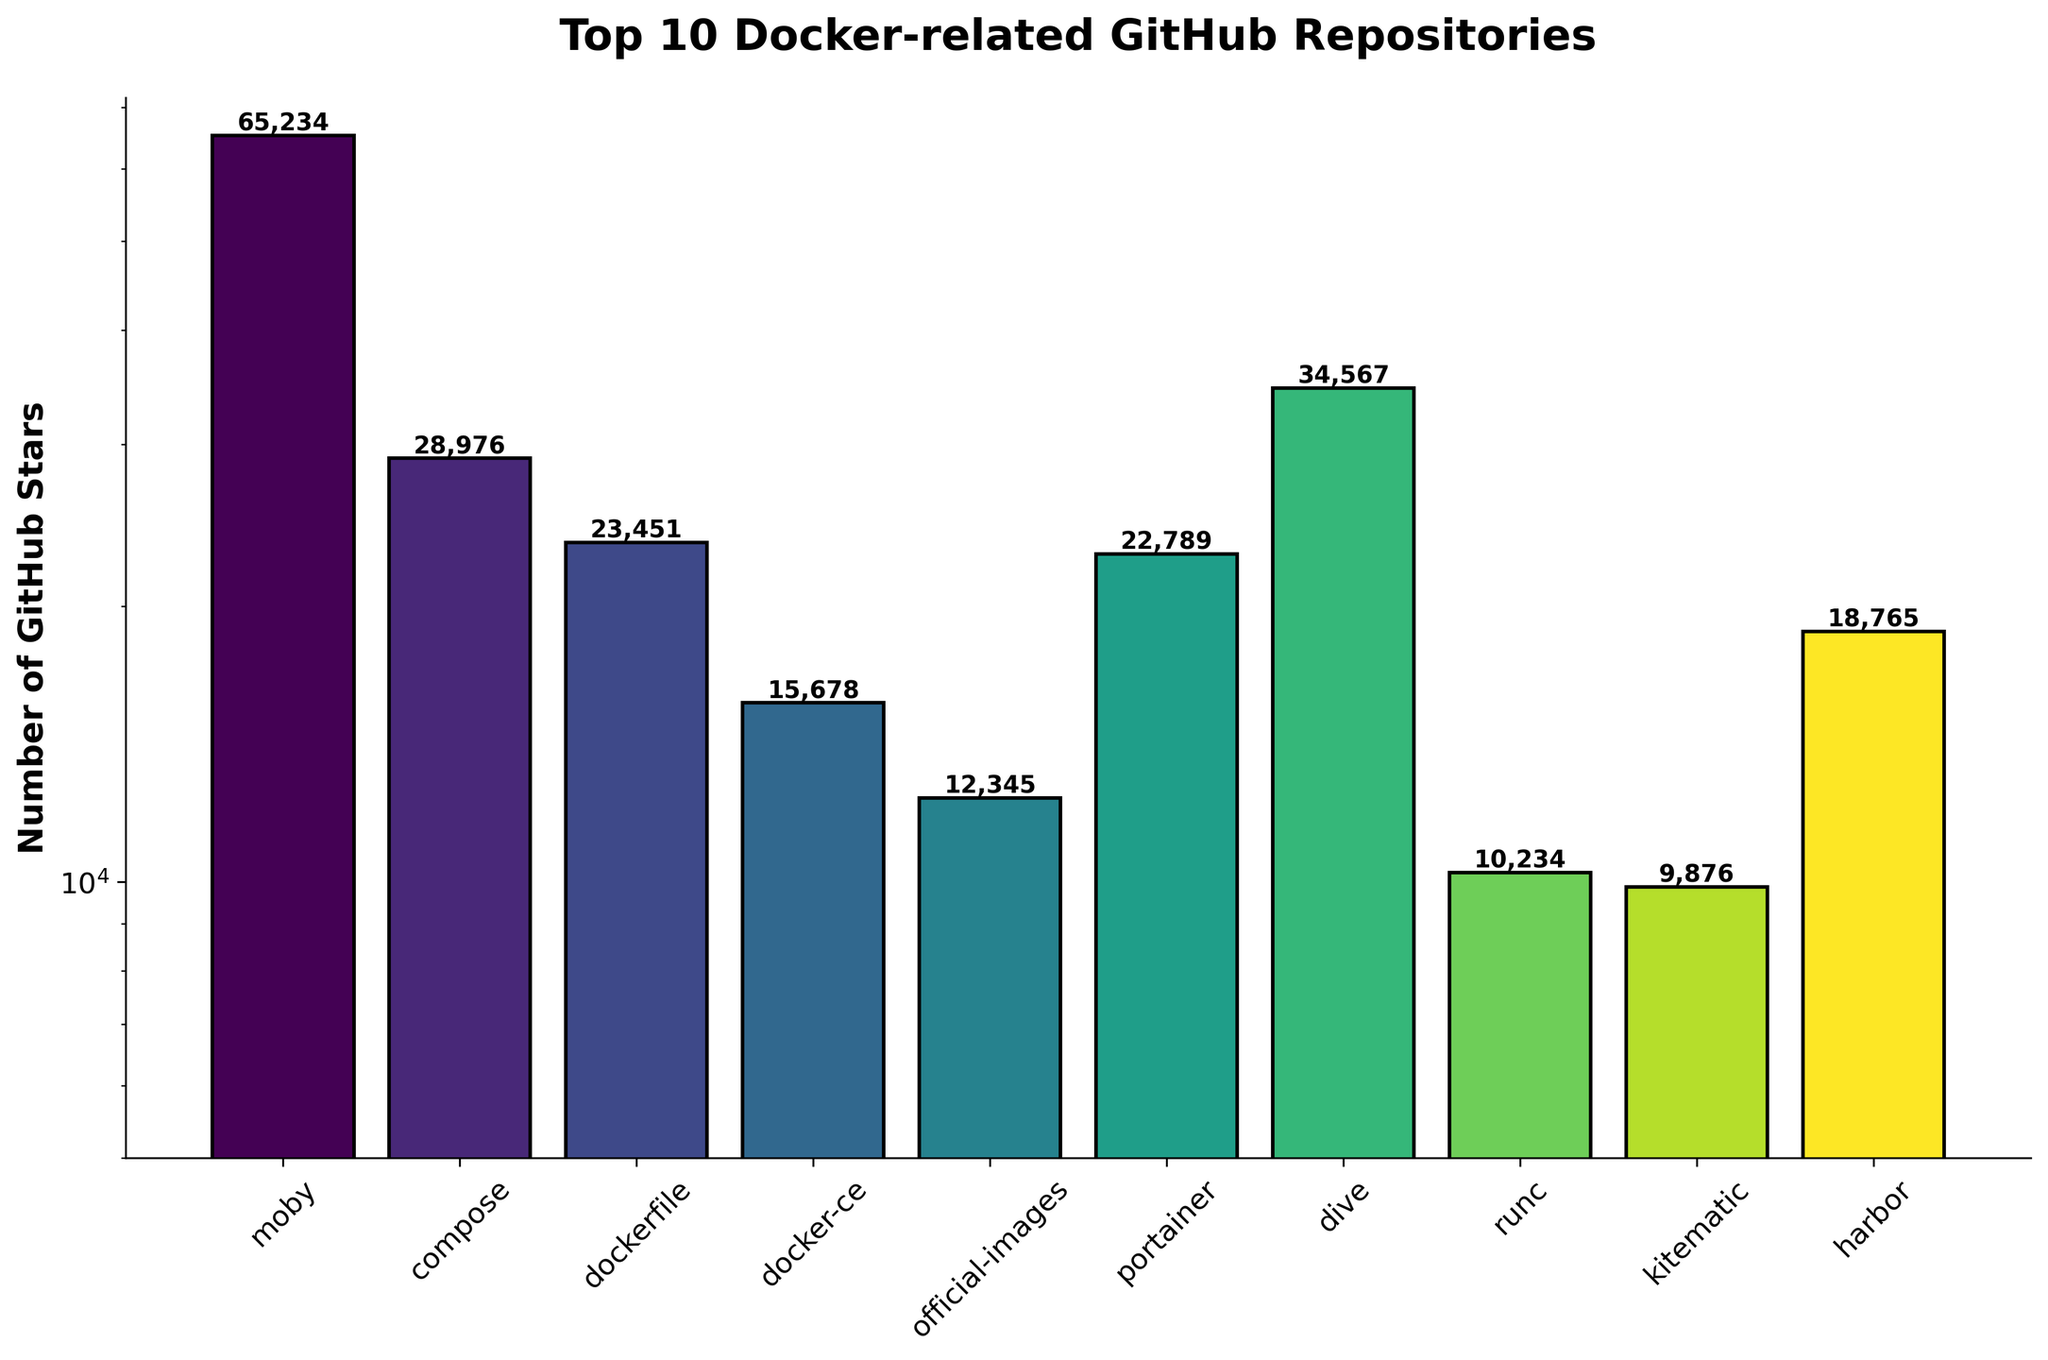Which repository has the highest number of stars? The bar representing 'moby' is the tallest, indicating it has the highest number of stars.
Answer: moby/moby Which repository has the lowest number of stars? The bar representing 'opencontainers' is the shortest, indicating it has the lowest number of stars.
Answer: opencontainers/runc What is the total number of GitHub stars for 'docker/compose' and 'docker/docker-ce'? 'docker/compose' has 28,976 stars and 'docker/docker-ce' has 15,678 stars. Adding these together gives 28,976 + 15,678 = 44,654 stars.
Answer: 44,654 How does the number of stars for 'docker/compose' compare to 'goharbor'? 'docker/compose' has 28,976 stars which is more than 'goharbor' with 18,765 stars.
Answer: More Is the number of stars for 'portainer' greater or less than 20,000? The bar for 'portainer' is slightly above 20,000 stars as it is at 22,789 stars.
Answer: Greater What's the difference in the number of stars between 'dockerfile/dockerfile' and 'wagoodman/dive'? 'dockerfile/dockerfile' has 23,451 stars and 'wagoodman/dive' has 34,567 stars. The difference is 34,567 - 23,451 = 11,116.
Answer: 11,116 How many repositories have a star count between 10,000 and 20,000? 'docker/docker-ce', 'goharbor', and 'opencontainers' fall within the 10,000 and 20,000 range.
Answer: 3 Which repository ranks third in the number of stars? The third tallest bar represents 'wagoodman/dive', indicating it ranks third in the number of stars.
Answer: wagoodman/dive 